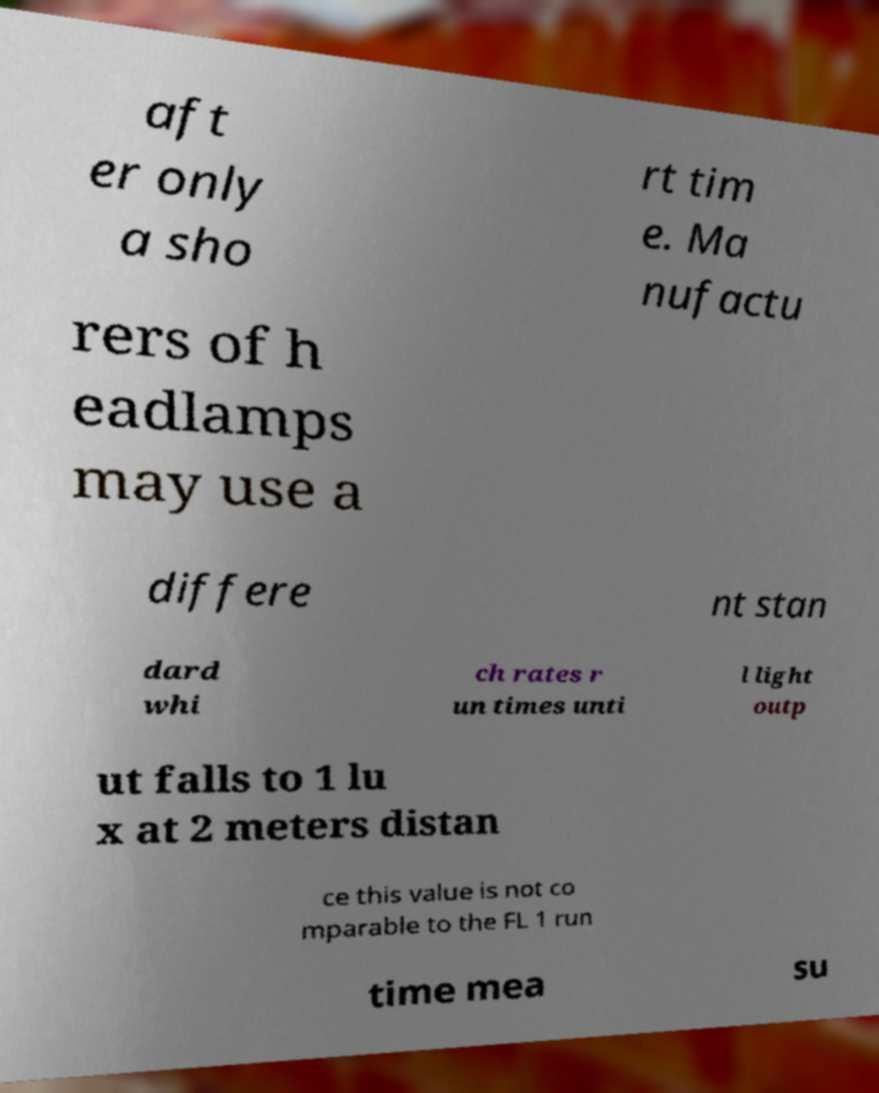What messages or text are displayed in this image? I need them in a readable, typed format. aft er only a sho rt tim e. Ma nufactu rers of h eadlamps may use a differe nt stan dard whi ch rates r un times unti l light outp ut falls to 1 lu x at 2 meters distan ce this value is not co mparable to the FL 1 run time mea su 